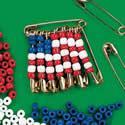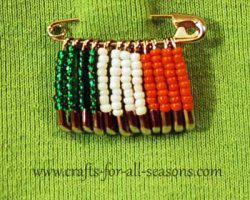The first image is the image on the left, the second image is the image on the right. Assess this claim about the two images: "The pin in the image on the left looks like an American flag.". Correct or not? Answer yes or no. Yes. The first image is the image on the left, the second image is the image on the right. Evaluate the accuracy of this statement regarding the images: "Left image includes an item made of beads, shaped like a Christmas tree with a star on top.". Is it true? Answer yes or no. No. 